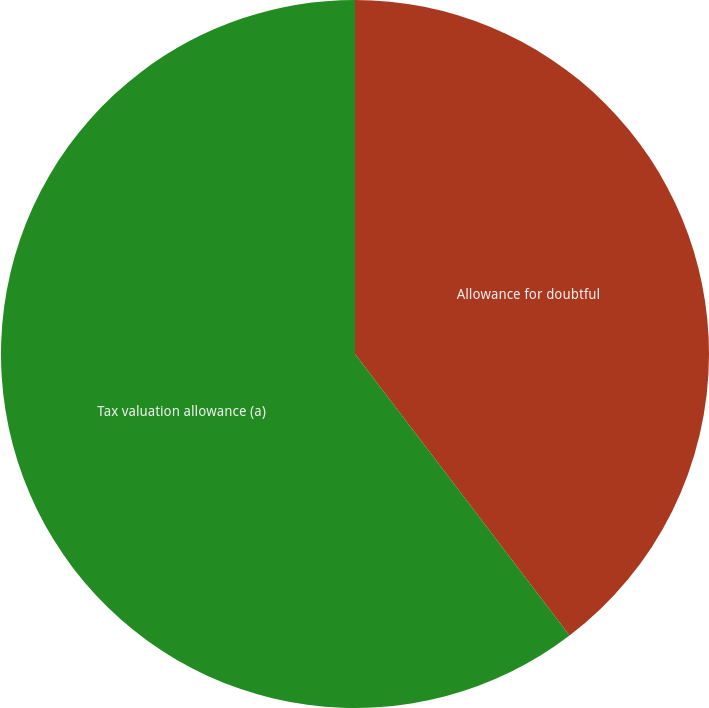<chart> <loc_0><loc_0><loc_500><loc_500><pie_chart><fcel>Allowance for doubtful<fcel>Tax valuation allowance (a)<nl><fcel>39.64%<fcel>60.36%<nl></chart> 